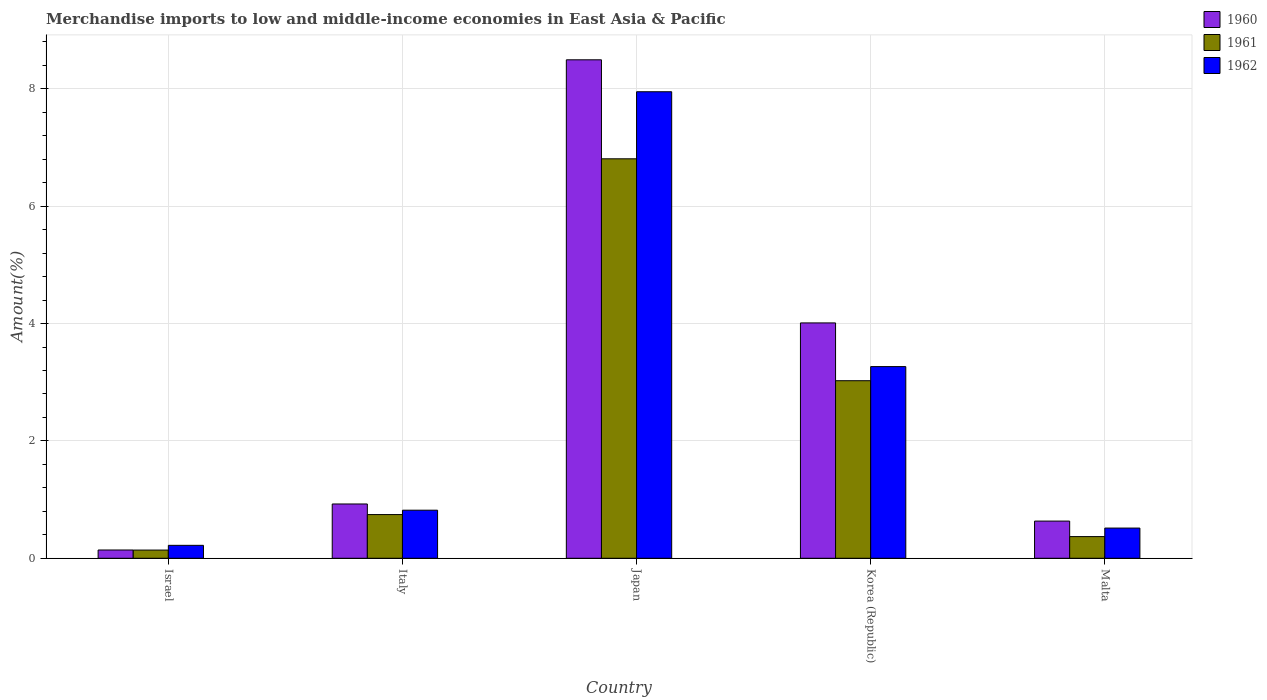How many groups of bars are there?
Provide a succinct answer. 5. How many bars are there on the 1st tick from the left?
Your answer should be compact. 3. What is the percentage of amount earned from merchandise imports in 1962 in Japan?
Your answer should be very brief. 7.95. Across all countries, what is the maximum percentage of amount earned from merchandise imports in 1962?
Keep it short and to the point. 7.95. Across all countries, what is the minimum percentage of amount earned from merchandise imports in 1962?
Your response must be concise. 0.22. In which country was the percentage of amount earned from merchandise imports in 1962 maximum?
Your answer should be compact. Japan. In which country was the percentage of amount earned from merchandise imports in 1960 minimum?
Your answer should be very brief. Israel. What is the total percentage of amount earned from merchandise imports in 1960 in the graph?
Ensure brevity in your answer.  14.21. What is the difference between the percentage of amount earned from merchandise imports in 1962 in Israel and that in Japan?
Give a very brief answer. -7.73. What is the difference between the percentage of amount earned from merchandise imports in 1961 in Korea (Republic) and the percentage of amount earned from merchandise imports in 1962 in Malta?
Your answer should be very brief. 2.51. What is the average percentage of amount earned from merchandise imports in 1960 per country?
Provide a short and direct response. 2.84. What is the difference between the percentage of amount earned from merchandise imports of/in 1961 and percentage of amount earned from merchandise imports of/in 1962 in Korea (Republic)?
Make the answer very short. -0.24. In how many countries, is the percentage of amount earned from merchandise imports in 1960 greater than 5.2 %?
Your answer should be compact. 1. What is the ratio of the percentage of amount earned from merchandise imports in 1960 in Japan to that in Malta?
Ensure brevity in your answer.  13.41. Is the difference between the percentage of amount earned from merchandise imports in 1961 in Italy and Korea (Republic) greater than the difference between the percentage of amount earned from merchandise imports in 1962 in Italy and Korea (Republic)?
Offer a terse response. Yes. What is the difference between the highest and the second highest percentage of amount earned from merchandise imports in 1962?
Your response must be concise. -2.45. What is the difference between the highest and the lowest percentage of amount earned from merchandise imports in 1961?
Give a very brief answer. 6.67. In how many countries, is the percentage of amount earned from merchandise imports in 1960 greater than the average percentage of amount earned from merchandise imports in 1960 taken over all countries?
Your answer should be very brief. 2. What does the 1st bar from the left in Korea (Republic) represents?
Ensure brevity in your answer.  1960. Is it the case that in every country, the sum of the percentage of amount earned from merchandise imports in 1961 and percentage of amount earned from merchandise imports in 1960 is greater than the percentage of amount earned from merchandise imports in 1962?
Keep it short and to the point. Yes. How many countries are there in the graph?
Your response must be concise. 5. What is the difference between two consecutive major ticks on the Y-axis?
Offer a very short reply. 2. Does the graph contain grids?
Ensure brevity in your answer.  Yes. Where does the legend appear in the graph?
Give a very brief answer. Top right. What is the title of the graph?
Keep it short and to the point. Merchandise imports to low and middle-income economies in East Asia & Pacific. What is the label or title of the Y-axis?
Make the answer very short. Amount(%). What is the Amount(%) in 1960 in Israel?
Offer a very short reply. 0.14. What is the Amount(%) in 1961 in Israel?
Your answer should be very brief. 0.14. What is the Amount(%) in 1962 in Israel?
Your answer should be very brief. 0.22. What is the Amount(%) in 1960 in Italy?
Make the answer very short. 0.93. What is the Amount(%) of 1961 in Italy?
Give a very brief answer. 0.74. What is the Amount(%) of 1962 in Italy?
Keep it short and to the point. 0.82. What is the Amount(%) in 1960 in Japan?
Provide a short and direct response. 8.5. What is the Amount(%) of 1961 in Japan?
Ensure brevity in your answer.  6.81. What is the Amount(%) in 1962 in Japan?
Provide a short and direct response. 7.95. What is the Amount(%) in 1960 in Korea (Republic)?
Ensure brevity in your answer.  4.01. What is the Amount(%) in 1961 in Korea (Republic)?
Ensure brevity in your answer.  3.03. What is the Amount(%) in 1962 in Korea (Republic)?
Your response must be concise. 3.27. What is the Amount(%) of 1960 in Malta?
Provide a short and direct response. 0.63. What is the Amount(%) in 1961 in Malta?
Provide a succinct answer. 0.37. What is the Amount(%) in 1962 in Malta?
Ensure brevity in your answer.  0.51. Across all countries, what is the maximum Amount(%) of 1960?
Make the answer very short. 8.5. Across all countries, what is the maximum Amount(%) in 1961?
Your answer should be compact. 6.81. Across all countries, what is the maximum Amount(%) in 1962?
Keep it short and to the point. 7.95. Across all countries, what is the minimum Amount(%) in 1960?
Ensure brevity in your answer.  0.14. Across all countries, what is the minimum Amount(%) in 1961?
Make the answer very short. 0.14. Across all countries, what is the minimum Amount(%) in 1962?
Make the answer very short. 0.22. What is the total Amount(%) of 1960 in the graph?
Offer a very short reply. 14.21. What is the total Amount(%) in 1961 in the graph?
Your answer should be compact. 11.09. What is the total Amount(%) in 1962 in the graph?
Keep it short and to the point. 12.77. What is the difference between the Amount(%) in 1960 in Israel and that in Italy?
Give a very brief answer. -0.78. What is the difference between the Amount(%) in 1961 in Israel and that in Italy?
Your answer should be very brief. -0.6. What is the difference between the Amount(%) of 1962 in Israel and that in Italy?
Keep it short and to the point. -0.6. What is the difference between the Amount(%) of 1960 in Israel and that in Japan?
Offer a terse response. -8.35. What is the difference between the Amount(%) of 1961 in Israel and that in Japan?
Your answer should be compact. -6.67. What is the difference between the Amount(%) in 1962 in Israel and that in Japan?
Give a very brief answer. -7.73. What is the difference between the Amount(%) of 1960 in Israel and that in Korea (Republic)?
Ensure brevity in your answer.  -3.87. What is the difference between the Amount(%) of 1961 in Israel and that in Korea (Republic)?
Provide a short and direct response. -2.89. What is the difference between the Amount(%) in 1962 in Israel and that in Korea (Republic)?
Keep it short and to the point. -3.05. What is the difference between the Amount(%) in 1960 in Israel and that in Malta?
Provide a succinct answer. -0.49. What is the difference between the Amount(%) in 1961 in Israel and that in Malta?
Your answer should be compact. -0.23. What is the difference between the Amount(%) in 1962 in Israel and that in Malta?
Provide a succinct answer. -0.29. What is the difference between the Amount(%) in 1960 in Italy and that in Japan?
Keep it short and to the point. -7.57. What is the difference between the Amount(%) of 1961 in Italy and that in Japan?
Offer a very short reply. -6.06. What is the difference between the Amount(%) in 1962 in Italy and that in Japan?
Your response must be concise. -7.13. What is the difference between the Amount(%) of 1960 in Italy and that in Korea (Republic)?
Offer a very short reply. -3.09. What is the difference between the Amount(%) of 1961 in Italy and that in Korea (Republic)?
Give a very brief answer. -2.28. What is the difference between the Amount(%) of 1962 in Italy and that in Korea (Republic)?
Ensure brevity in your answer.  -2.45. What is the difference between the Amount(%) in 1960 in Italy and that in Malta?
Make the answer very short. 0.29. What is the difference between the Amount(%) in 1961 in Italy and that in Malta?
Offer a terse response. 0.38. What is the difference between the Amount(%) of 1962 in Italy and that in Malta?
Offer a very short reply. 0.3. What is the difference between the Amount(%) of 1960 in Japan and that in Korea (Republic)?
Provide a short and direct response. 4.48. What is the difference between the Amount(%) of 1961 in Japan and that in Korea (Republic)?
Keep it short and to the point. 3.78. What is the difference between the Amount(%) of 1962 in Japan and that in Korea (Republic)?
Keep it short and to the point. 4.68. What is the difference between the Amount(%) in 1960 in Japan and that in Malta?
Offer a terse response. 7.86. What is the difference between the Amount(%) of 1961 in Japan and that in Malta?
Offer a terse response. 6.44. What is the difference between the Amount(%) of 1962 in Japan and that in Malta?
Give a very brief answer. 7.44. What is the difference between the Amount(%) in 1960 in Korea (Republic) and that in Malta?
Provide a succinct answer. 3.38. What is the difference between the Amount(%) of 1961 in Korea (Republic) and that in Malta?
Offer a terse response. 2.66. What is the difference between the Amount(%) of 1962 in Korea (Republic) and that in Malta?
Provide a short and direct response. 2.75. What is the difference between the Amount(%) of 1960 in Israel and the Amount(%) of 1961 in Italy?
Your response must be concise. -0.6. What is the difference between the Amount(%) in 1960 in Israel and the Amount(%) in 1962 in Italy?
Keep it short and to the point. -0.68. What is the difference between the Amount(%) of 1961 in Israel and the Amount(%) of 1962 in Italy?
Provide a succinct answer. -0.68. What is the difference between the Amount(%) in 1960 in Israel and the Amount(%) in 1961 in Japan?
Give a very brief answer. -6.67. What is the difference between the Amount(%) in 1960 in Israel and the Amount(%) in 1962 in Japan?
Make the answer very short. -7.81. What is the difference between the Amount(%) in 1961 in Israel and the Amount(%) in 1962 in Japan?
Your answer should be compact. -7.81. What is the difference between the Amount(%) of 1960 in Israel and the Amount(%) of 1961 in Korea (Republic)?
Your response must be concise. -2.89. What is the difference between the Amount(%) of 1960 in Israel and the Amount(%) of 1962 in Korea (Republic)?
Provide a short and direct response. -3.13. What is the difference between the Amount(%) in 1961 in Israel and the Amount(%) in 1962 in Korea (Republic)?
Provide a short and direct response. -3.13. What is the difference between the Amount(%) of 1960 in Israel and the Amount(%) of 1961 in Malta?
Your answer should be very brief. -0.23. What is the difference between the Amount(%) of 1960 in Israel and the Amount(%) of 1962 in Malta?
Your answer should be compact. -0.37. What is the difference between the Amount(%) in 1961 in Israel and the Amount(%) in 1962 in Malta?
Your answer should be very brief. -0.37. What is the difference between the Amount(%) in 1960 in Italy and the Amount(%) in 1961 in Japan?
Ensure brevity in your answer.  -5.88. What is the difference between the Amount(%) in 1960 in Italy and the Amount(%) in 1962 in Japan?
Offer a terse response. -7.03. What is the difference between the Amount(%) in 1961 in Italy and the Amount(%) in 1962 in Japan?
Ensure brevity in your answer.  -7.21. What is the difference between the Amount(%) of 1960 in Italy and the Amount(%) of 1961 in Korea (Republic)?
Your answer should be compact. -2.1. What is the difference between the Amount(%) in 1960 in Italy and the Amount(%) in 1962 in Korea (Republic)?
Make the answer very short. -2.34. What is the difference between the Amount(%) of 1961 in Italy and the Amount(%) of 1962 in Korea (Republic)?
Offer a very short reply. -2.52. What is the difference between the Amount(%) of 1960 in Italy and the Amount(%) of 1961 in Malta?
Provide a succinct answer. 0.56. What is the difference between the Amount(%) of 1960 in Italy and the Amount(%) of 1962 in Malta?
Keep it short and to the point. 0.41. What is the difference between the Amount(%) of 1961 in Italy and the Amount(%) of 1962 in Malta?
Make the answer very short. 0.23. What is the difference between the Amount(%) of 1960 in Japan and the Amount(%) of 1961 in Korea (Republic)?
Make the answer very short. 5.47. What is the difference between the Amount(%) in 1960 in Japan and the Amount(%) in 1962 in Korea (Republic)?
Your answer should be compact. 5.23. What is the difference between the Amount(%) in 1961 in Japan and the Amount(%) in 1962 in Korea (Republic)?
Your answer should be compact. 3.54. What is the difference between the Amount(%) of 1960 in Japan and the Amount(%) of 1961 in Malta?
Keep it short and to the point. 8.13. What is the difference between the Amount(%) in 1960 in Japan and the Amount(%) in 1962 in Malta?
Ensure brevity in your answer.  7.98. What is the difference between the Amount(%) of 1961 in Japan and the Amount(%) of 1962 in Malta?
Provide a short and direct response. 6.29. What is the difference between the Amount(%) in 1960 in Korea (Republic) and the Amount(%) in 1961 in Malta?
Offer a terse response. 3.64. What is the difference between the Amount(%) in 1960 in Korea (Republic) and the Amount(%) in 1962 in Malta?
Make the answer very short. 3.5. What is the difference between the Amount(%) of 1961 in Korea (Republic) and the Amount(%) of 1962 in Malta?
Offer a terse response. 2.51. What is the average Amount(%) in 1960 per country?
Your answer should be compact. 2.84. What is the average Amount(%) of 1961 per country?
Your answer should be compact. 2.22. What is the average Amount(%) of 1962 per country?
Your answer should be very brief. 2.55. What is the difference between the Amount(%) of 1960 and Amount(%) of 1961 in Israel?
Provide a succinct answer. 0. What is the difference between the Amount(%) in 1960 and Amount(%) in 1962 in Israel?
Provide a succinct answer. -0.08. What is the difference between the Amount(%) of 1961 and Amount(%) of 1962 in Israel?
Ensure brevity in your answer.  -0.08. What is the difference between the Amount(%) in 1960 and Amount(%) in 1961 in Italy?
Your answer should be very brief. 0.18. What is the difference between the Amount(%) of 1960 and Amount(%) of 1962 in Italy?
Offer a terse response. 0.11. What is the difference between the Amount(%) in 1961 and Amount(%) in 1962 in Italy?
Offer a very short reply. -0.07. What is the difference between the Amount(%) in 1960 and Amount(%) in 1961 in Japan?
Make the answer very short. 1.69. What is the difference between the Amount(%) of 1960 and Amount(%) of 1962 in Japan?
Offer a terse response. 0.54. What is the difference between the Amount(%) of 1961 and Amount(%) of 1962 in Japan?
Give a very brief answer. -1.14. What is the difference between the Amount(%) in 1960 and Amount(%) in 1961 in Korea (Republic)?
Ensure brevity in your answer.  0.99. What is the difference between the Amount(%) of 1960 and Amount(%) of 1962 in Korea (Republic)?
Provide a short and direct response. 0.74. What is the difference between the Amount(%) in 1961 and Amount(%) in 1962 in Korea (Republic)?
Ensure brevity in your answer.  -0.24. What is the difference between the Amount(%) of 1960 and Amount(%) of 1961 in Malta?
Provide a succinct answer. 0.26. What is the difference between the Amount(%) in 1960 and Amount(%) in 1962 in Malta?
Offer a very short reply. 0.12. What is the difference between the Amount(%) in 1961 and Amount(%) in 1962 in Malta?
Your answer should be compact. -0.15. What is the ratio of the Amount(%) in 1960 in Israel to that in Italy?
Your response must be concise. 0.15. What is the ratio of the Amount(%) in 1961 in Israel to that in Italy?
Make the answer very short. 0.19. What is the ratio of the Amount(%) in 1962 in Israel to that in Italy?
Provide a succinct answer. 0.27. What is the ratio of the Amount(%) in 1960 in Israel to that in Japan?
Provide a short and direct response. 0.02. What is the ratio of the Amount(%) in 1961 in Israel to that in Japan?
Make the answer very short. 0.02. What is the ratio of the Amount(%) in 1962 in Israel to that in Japan?
Your answer should be compact. 0.03. What is the ratio of the Amount(%) in 1960 in Israel to that in Korea (Republic)?
Offer a very short reply. 0.04. What is the ratio of the Amount(%) of 1961 in Israel to that in Korea (Republic)?
Give a very brief answer. 0.05. What is the ratio of the Amount(%) in 1962 in Israel to that in Korea (Republic)?
Offer a very short reply. 0.07. What is the ratio of the Amount(%) in 1960 in Israel to that in Malta?
Provide a succinct answer. 0.22. What is the ratio of the Amount(%) of 1961 in Israel to that in Malta?
Make the answer very short. 0.38. What is the ratio of the Amount(%) of 1962 in Israel to that in Malta?
Provide a succinct answer. 0.43. What is the ratio of the Amount(%) of 1960 in Italy to that in Japan?
Make the answer very short. 0.11. What is the ratio of the Amount(%) in 1961 in Italy to that in Japan?
Offer a very short reply. 0.11. What is the ratio of the Amount(%) of 1962 in Italy to that in Japan?
Keep it short and to the point. 0.1. What is the ratio of the Amount(%) of 1960 in Italy to that in Korea (Republic)?
Keep it short and to the point. 0.23. What is the ratio of the Amount(%) in 1961 in Italy to that in Korea (Republic)?
Keep it short and to the point. 0.25. What is the ratio of the Amount(%) of 1962 in Italy to that in Korea (Republic)?
Keep it short and to the point. 0.25. What is the ratio of the Amount(%) in 1960 in Italy to that in Malta?
Your answer should be very brief. 1.46. What is the ratio of the Amount(%) of 1961 in Italy to that in Malta?
Give a very brief answer. 2.02. What is the ratio of the Amount(%) of 1962 in Italy to that in Malta?
Your response must be concise. 1.59. What is the ratio of the Amount(%) of 1960 in Japan to that in Korea (Republic)?
Provide a succinct answer. 2.12. What is the ratio of the Amount(%) of 1961 in Japan to that in Korea (Republic)?
Provide a succinct answer. 2.25. What is the ratio of the Amount(%) in 1962 in Japan to that in Korea (Republic)?
Your response must be concise. 2.43. What is the ratio of the Amount(%) of 1960 in Japan to that in Malta?
Provide a succinct answer. 13.41. What is the ratio of the Amount(%) of 1961 in Japan to that in Malta?
Give a very brief answer. 18.43. What is the ratio of the Amount(%) in 1962 in Japan to that in Malta?
Your answer should be very brief. 15.45. What is the ratio of the Amount(%) of 1960 in Korea (Republic) to that in Malta?
Make the answer very short. 6.33. What is the ratio of the Amount(%) in 1961 in Korea (Republic) to that in Malta?
Offer a very short reply. 8.19. What is the ratio of the Amount(%) in 1962 in Korea (Republic) to that in Malta?
Ensure brevity in your answer.  6.35. What is the difference between the highest and the second highest Amount(%) in 1960?
Offer a terse response. 4.48. What is the difference between the highest and the second highest Amount(%) in 1961?
Make the answer very short. 3.78. What is the difference between the highest and the second highest Amount(%) of 1962?
Provide a short and direct response. 4.68. What is the difference between the highest and the lowest Amount(%) of 1960?
Your answer should be very brief. 8.35. What is the difference between the highest and the lowest Amount(%) in 1961?
Ensure brevity in your answer.  6.67. What is the difference between the highest and the lowest Amount(%) of 1962?
Keep it short and to the point. 7.73. 